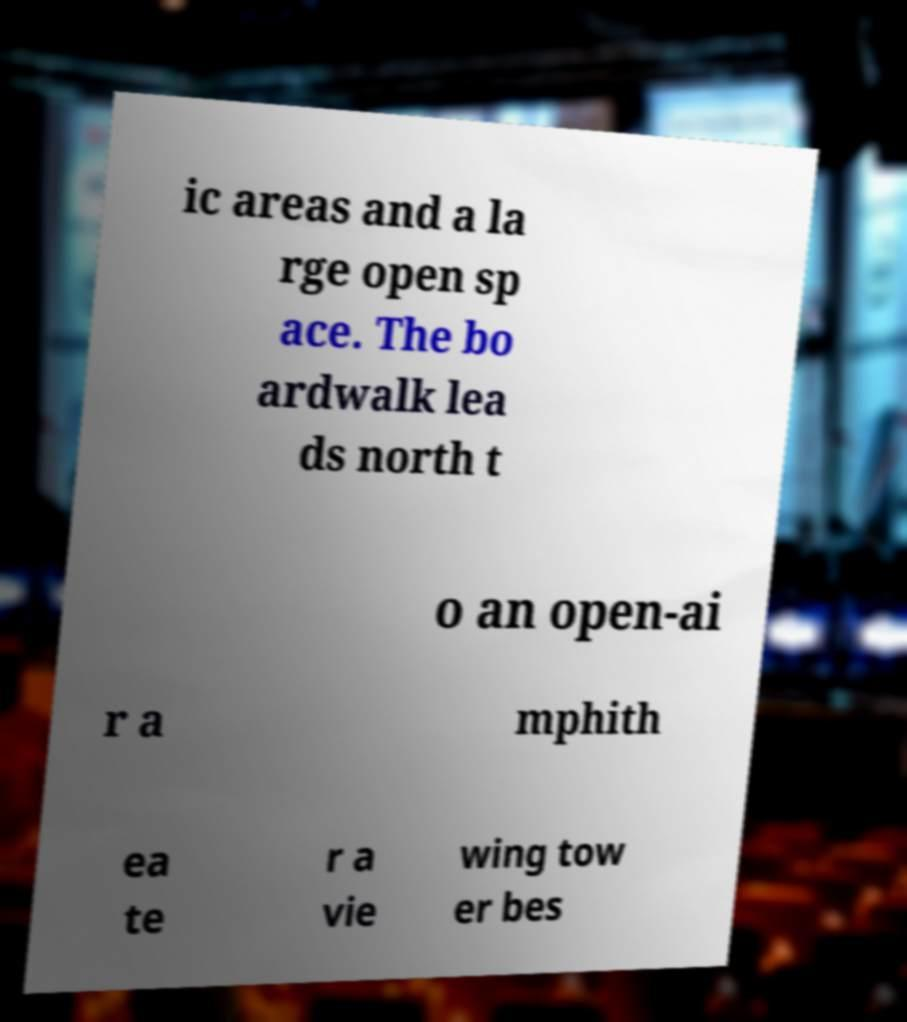Please read and relay the text visible in this image. What does it say? ic areas and a la rge open sp ace. The bo ardwalk lea ds north t o an open-ai r a mphith ea te r a vie wing tow er bes 